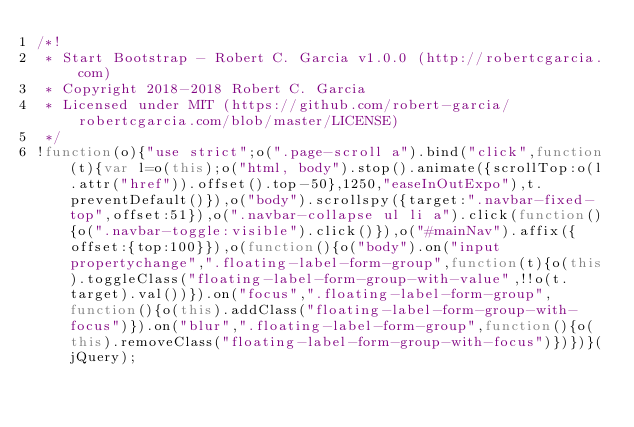<code> <loc_0><loc_0><loc_500><loc_500><_JavaScript_>/*!
 * Start Bootstrap - Robert C. Garcia v1.0.0 (http://robertcgarcia.com)
 * Copyright 2018-2018 Robert C. Garcia
 * Licensed under MIT (https://github.com/robert-garcia/robertcgarcia.com/blob/master/LICENSE)
 */
!function(o){"use strict";o(".page-scroll a").bind("click",function(t){var l=o(this);o("html, body").stop().animate({scrollTop:o(l.attr("href")).offset().top-50},1250,"easeInOutExpo"),t.preventDefault()}),o("body").scrollspy({target:".navbar-fixed-top",offset:51}),o(".navbar-collapse ul li a").click(function(){o(".navbar-toggle:visible").click()}),o("#mainNav").affix({offset:{top:100}}),o(function(){o("body").on("input propertychange",".floating-label-form-group",function(t){o(this).toggleClass("floating-label-form-group-with-value",!!o(t.target).val())}).on("focus",".floating-label-form-group",function(){o(this).addClass("floating-label-form-group-with-focus")}).on("blur",".floating-label-form-group",function(){o(this).removeClass("floating-label-form-group-with-focus")})})}(jQuery);</code> 